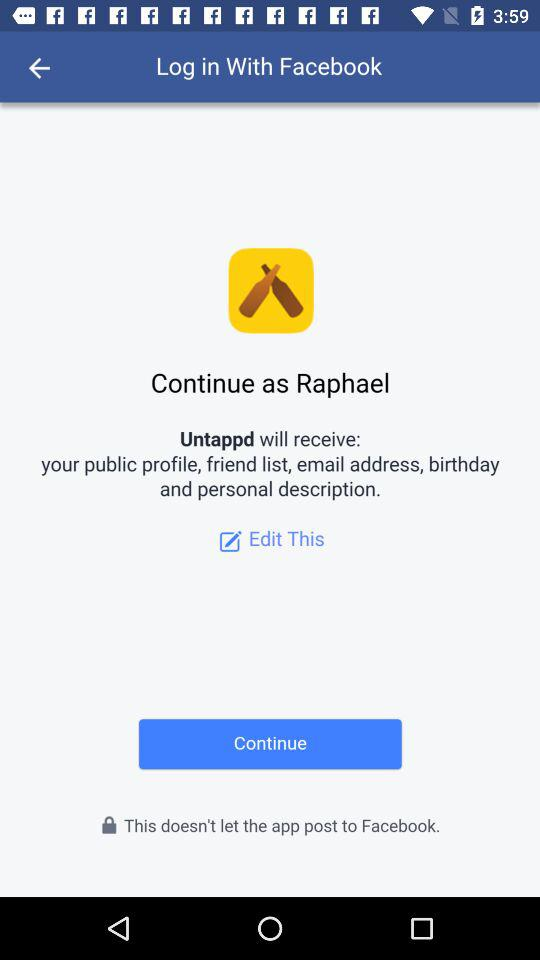Through what application can the user log in with? The user can log in with "Facebook". 